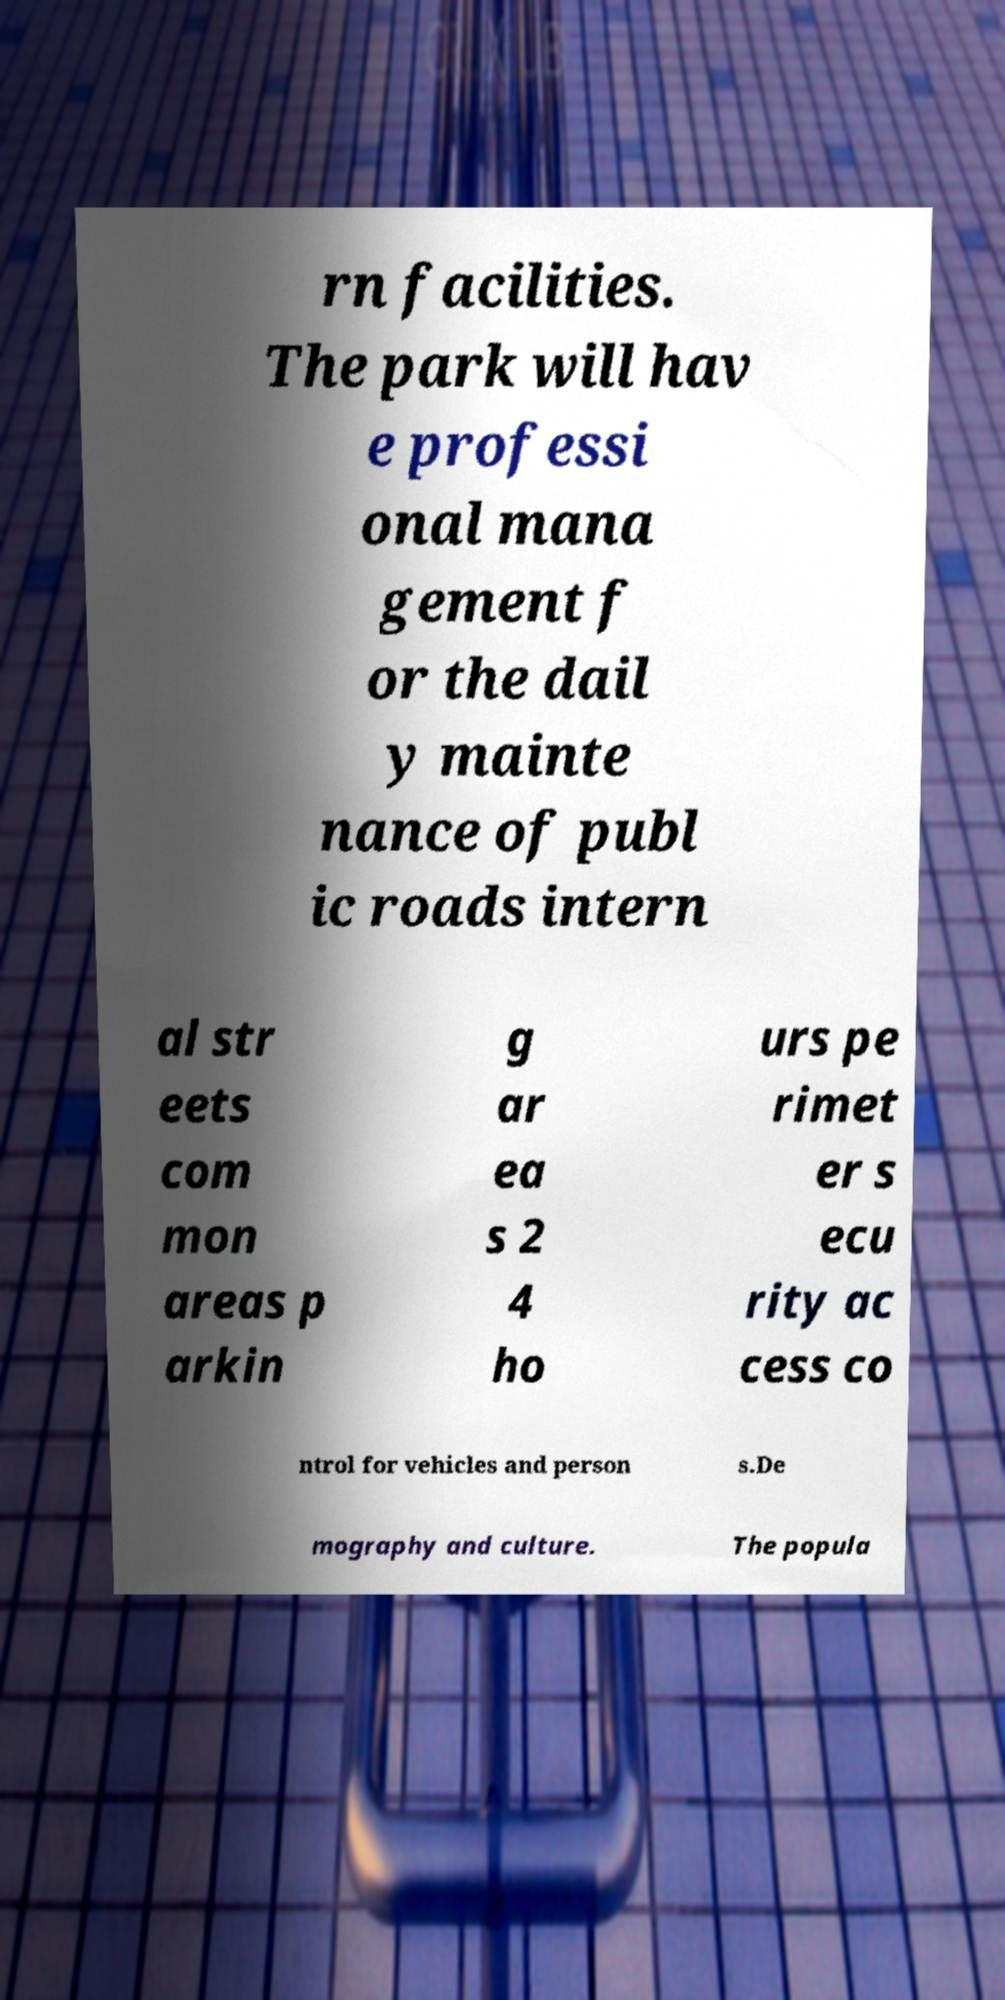Please identify and transcribe the text found in this image. rn facilities. The park will hav e professi onal mana gement f or the dail y mainte nance of publ ic roads intern al str eets com mon areas p arkin g ar ea s 2 4 ho urs pe rimet er s ecu rity ac cess co ntrol for vehicles and person s.De mography and culture. The popula 